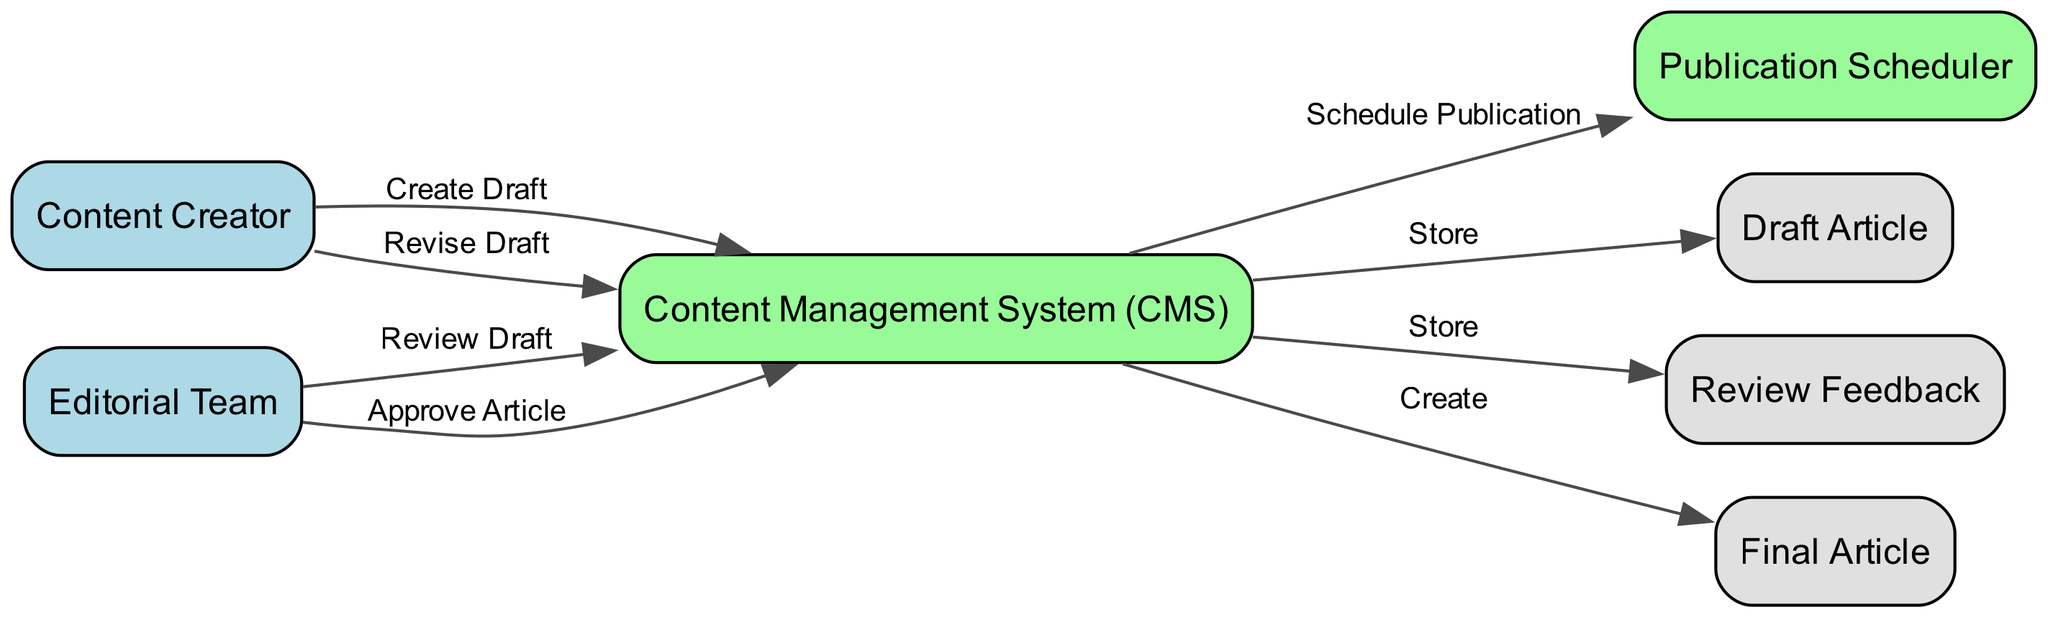What is the first action taken in this workflow? The first action in the workflow starts with the Content Creator, who creates a draft. This is the initial step and is designated by the directed edge from "Content Creator" to "Content Management System (CMS)" labeled "Create Draft".
Answer: Create Draft Who is responsible for reviewing the draft? The Editorial Team is tasked with reviewing the draft. This is indicated by the edge connecting "Editorial Team" to "Content Management System (CMS)" with the label "Review Draft".
Answer: Editorial Team How many objects are represented in the diagram? There are three objects present in the diagram: Draft Article, Review Feedback, and Final Article. This can be counted by identifying the different objects mentioned in the data provided.
Answer: Three What does the Editorial Team do after reviewing the draft? After reviewing the draft, the Editorial Team either approves or provides feedback on the draft. The specific action shown in the diagram is "Approve Article", which indicates their approval process.
Answer: Approve Article What action does the Content Creator take after receiving review feedback? The Content Creator revises the draft after receiving the review feedback. This is shown by the edge from "Content Management System (CMS)" back to "Content Creator" labeled "Revise Draft", indicating modification based on provided feedback.
Answer: Revise Draft How is the final article created? The final article is created by the Content Management System (CMS) once the article is approved by the Editorial Team. This flow is represented by the edge from "Content Management System (CMS)" to "Final Article" labeled "Create".
Answer: Create Which system is responsible for scheduling publication? The Publication Scheduler system is responsible for scheduling the publication of the finalized article. This is indicated by the directed edge from "Content Management System (CMS)" to "Publication Scheduler" labeled "Schedule Publication".
Answer: Publication Scheduler What feedback is stored in the workflow? The Review Feedback object is stored in the workflow after the Editorial Team reviews the draft. This is represented by the edge from "Content Management System (CMS)" to "Review Feedback", indicating the storage and reference of feedback received.
Answer: Review Feedback 